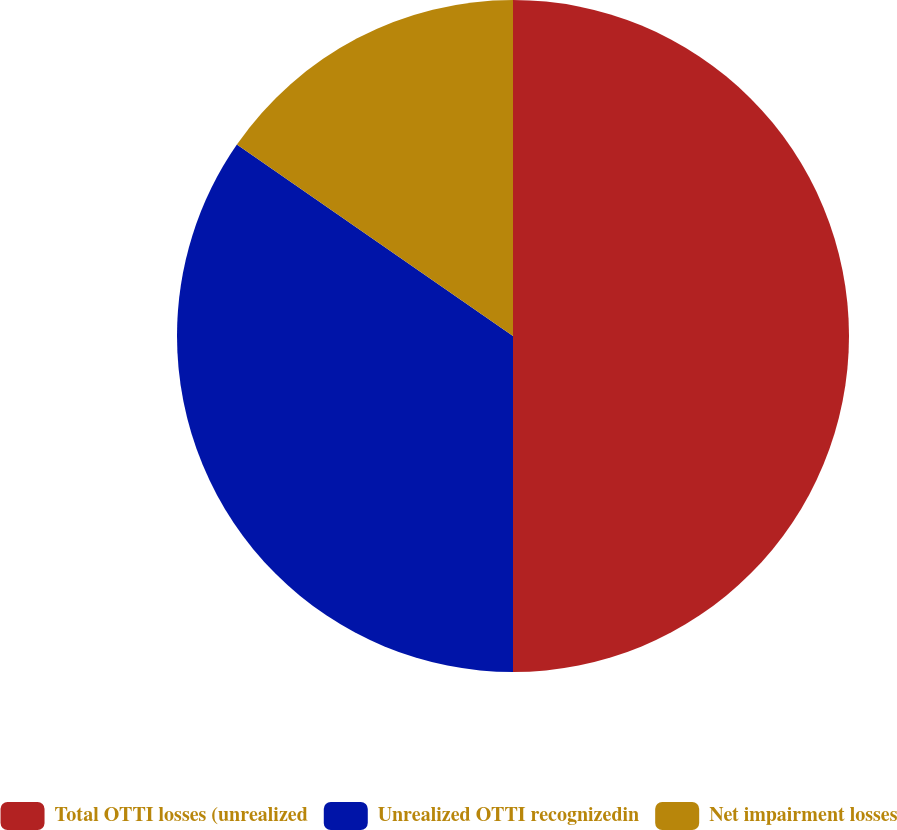Convert chart to OTSL. <chart><loc_0><loc_0><loc_500><loc_500><pie_chart><fcel>Total OTTI losses (unrealized<fcel>Unrealized OTTI recognizedin<fcel>Net impairment losses<nl><fcel>50.0%<fcel>34.65%<fcel>15.35%<nl></chart> 